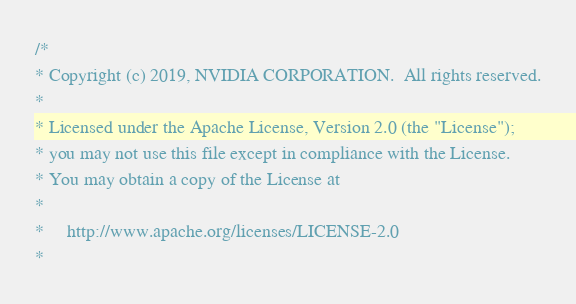<code> <loc_0><loc_0><loc_500><loc_500><_Cuda_>/*
* Copyright (c) 2019, NVIDIA CORPORATION.  All rights reserved.
*
* Licensed under the Apache License, Version 2.0 (the "License");
* you may not use this file except in compliance with the License.
* You may obtain a copy of the License at
*
*     http://www.apache.org/licenses/LICENSE-2.0
*</code> 